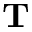Convert formula to latex. <formula><loc_0><loc_0><loc_500><loc_500>T</formula> 